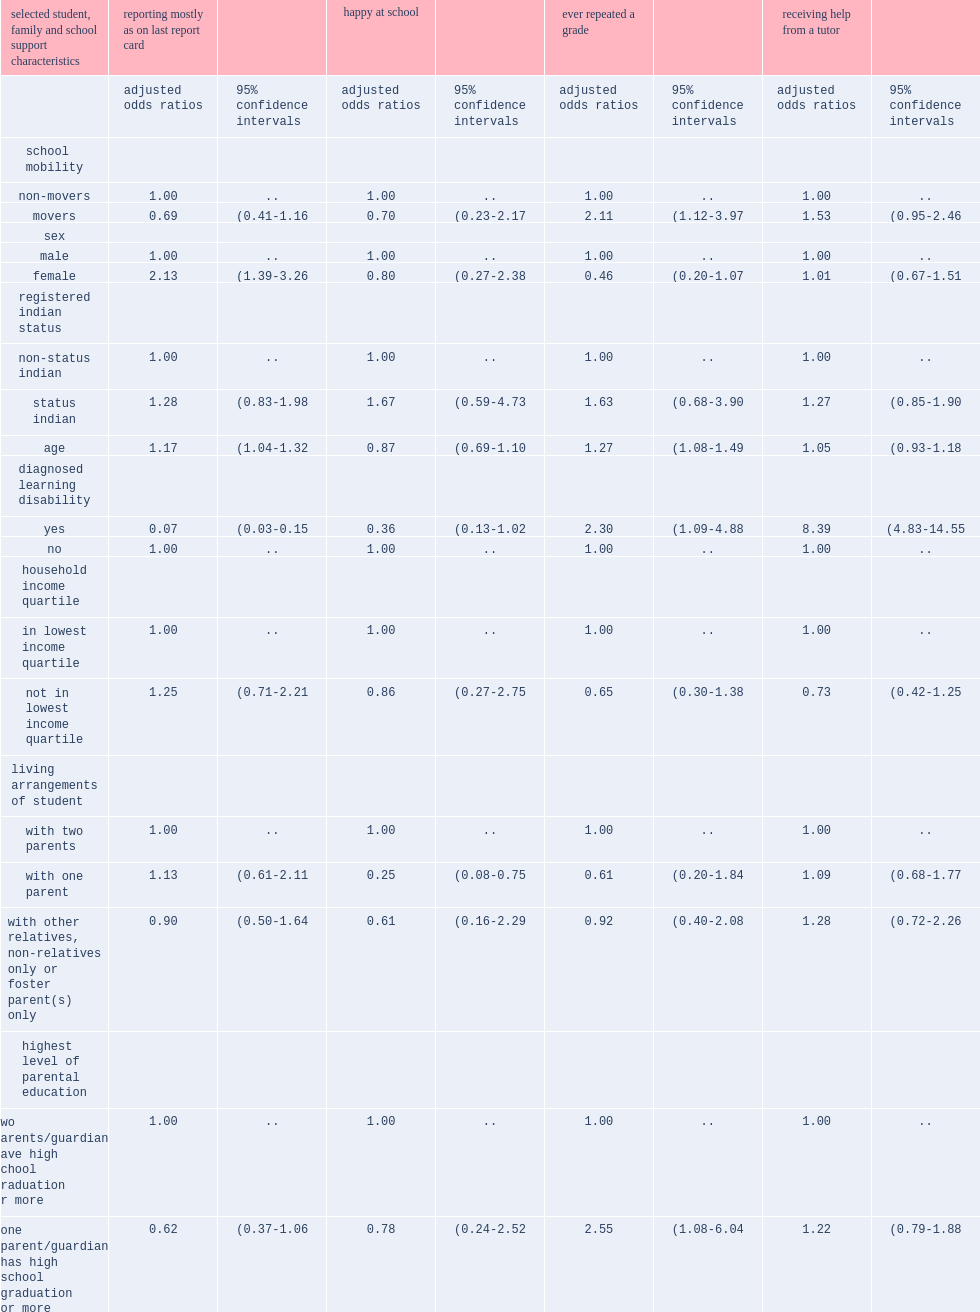What was the odds of ever repeating a grade among movers? 1.0. What was the odds of ever repeating a grade among non-movers? 2.11. Which type was more likely to have ever repeated a grade, movers or non-movers? Movers. 